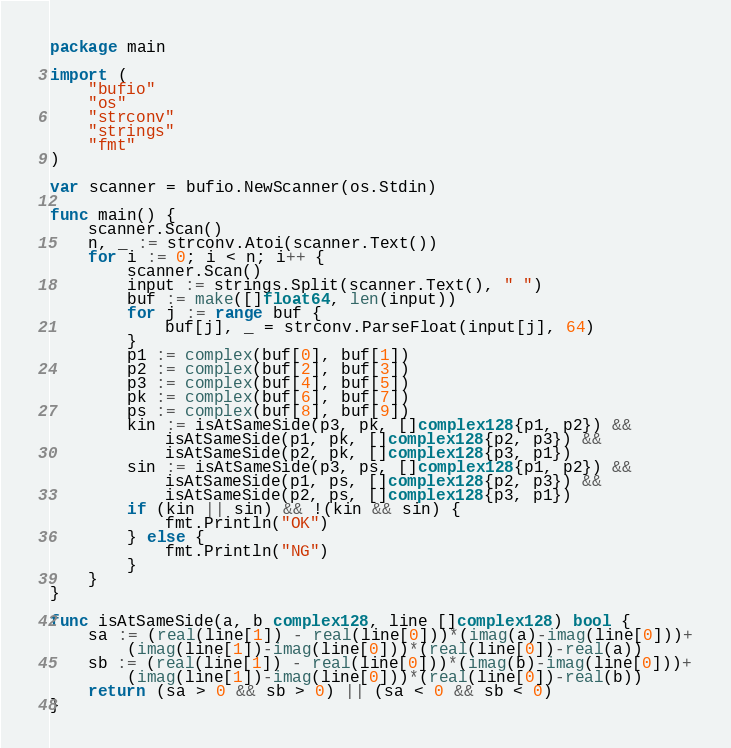Convert code to text. <code><loc_0><loc_0><loc_500><loc_500><_Go_>package main

import (
	"bufio"
	"os"
	"strconv"
	"strings"
	"fmt"
)

var scanner = bufio.NewScanner(os.Stdin)

func main() {
	scanner.Scan()
	n, _ := strconv.Atoi(scanner.Text())
	for i := 0; i < n; i++ {
		scanner.Scan()
		input := strings.Split(scanner.Text(), " ")
		buf := make([]float64, len(input))
		for j := range buf {
			buf[j], _ = strconv.ParseFloat(input[j], 64)
		}
		p1 := complex(buf[0], buf[1])
		p2 := complex(buf[2], buf[3])
		p3 := complex(buf[4], buf[5])
		pk := complex(buf[6], buf[7])
		ps := complex(buf[8], buf[9])
		kin := isAtSameSide(p3, pk, []complex128{p1, p2}) &&
			isAtSameSide(p1, pk, []complex128{p2, p3}) &&
			isAtSameSide(p2, pk, []complex128{p3, p1})
		sin := isAtSameSide(p3, ps, []complex128{p1, p2}) &&
			isAtSameSide(p1, ps, []complex128{p2, p3}) &&
			isAtSameSide(p2, ps, []complex128{p3, p1})
		if (kin || sin) && !(kin && sin) {
			fmt.Println("OK")
		} else {
			fmt.Println("NG")
		}
	}
}

func isAtSameSide(a, b complex128, line []complex128) bool {
	sa := (real(line[1]) - real(line[0]))*(imag(a)-imag(line[0]))+
		(imag(line[1])-imag(line[0]))*(real(line[0])-real(a))
	sb := (real(line[1]) - real(line[0]))*(imag(b)-imag(line[0]))+
		(imag(line[1])-imag(line[0]))*(real(line[0])-real(b))
	return (sa > 0 && sb > 0) || (sa < 0 && sb < 0)
}
</code> 